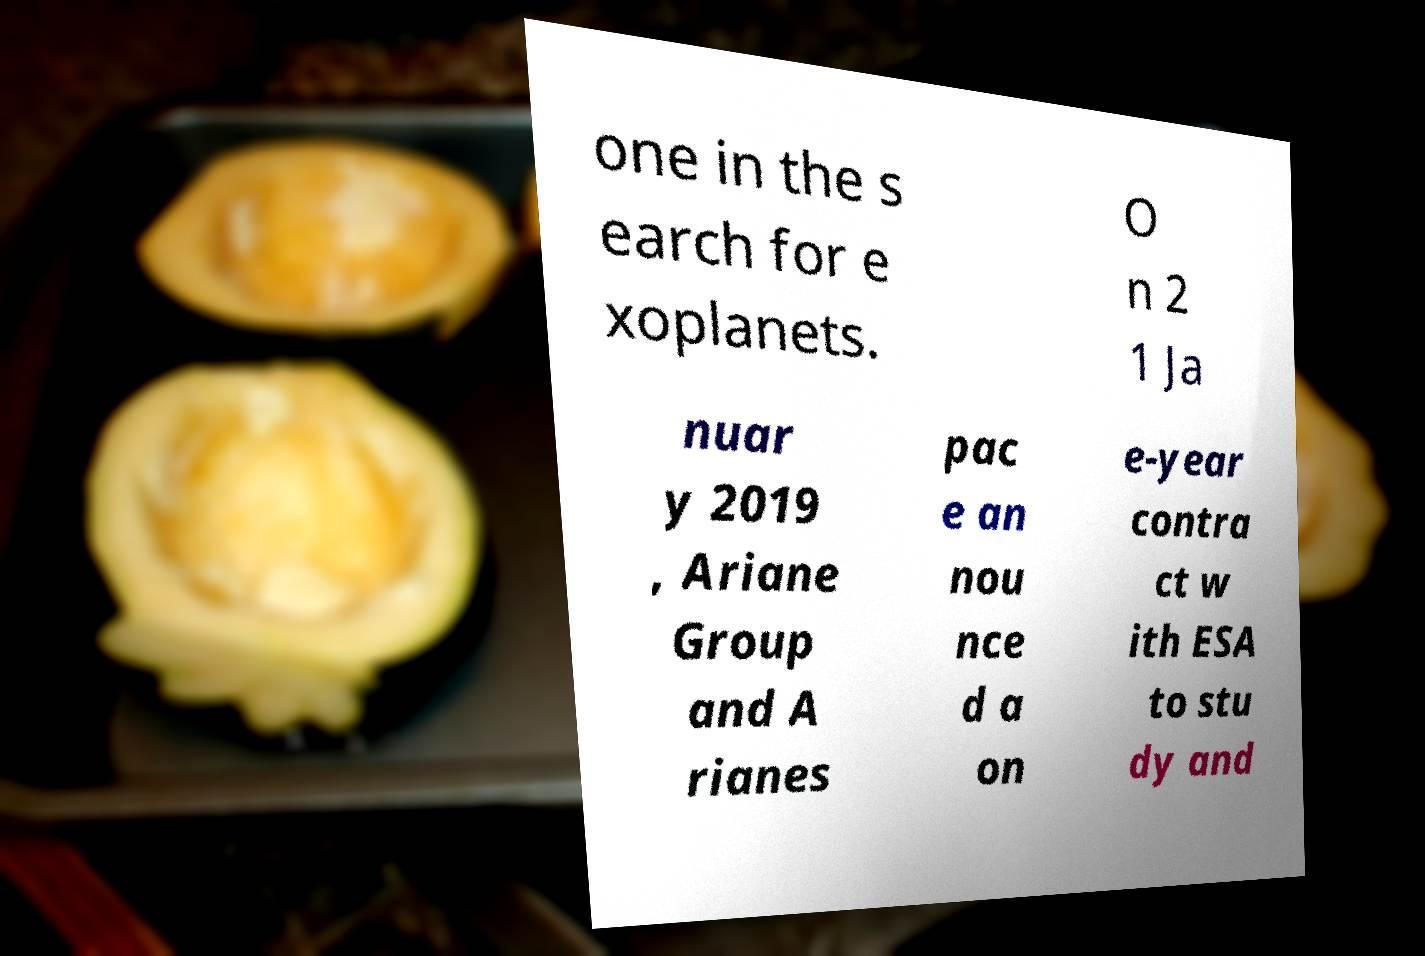Could you extract and type out the text from this image? one in the s earch for e xoplanets. O n 2 1 Ja nuar y 2019 , Ariane Group and A rianes pac e an nou nce d a on e-year contra ct w ith ESA to stu dy and 